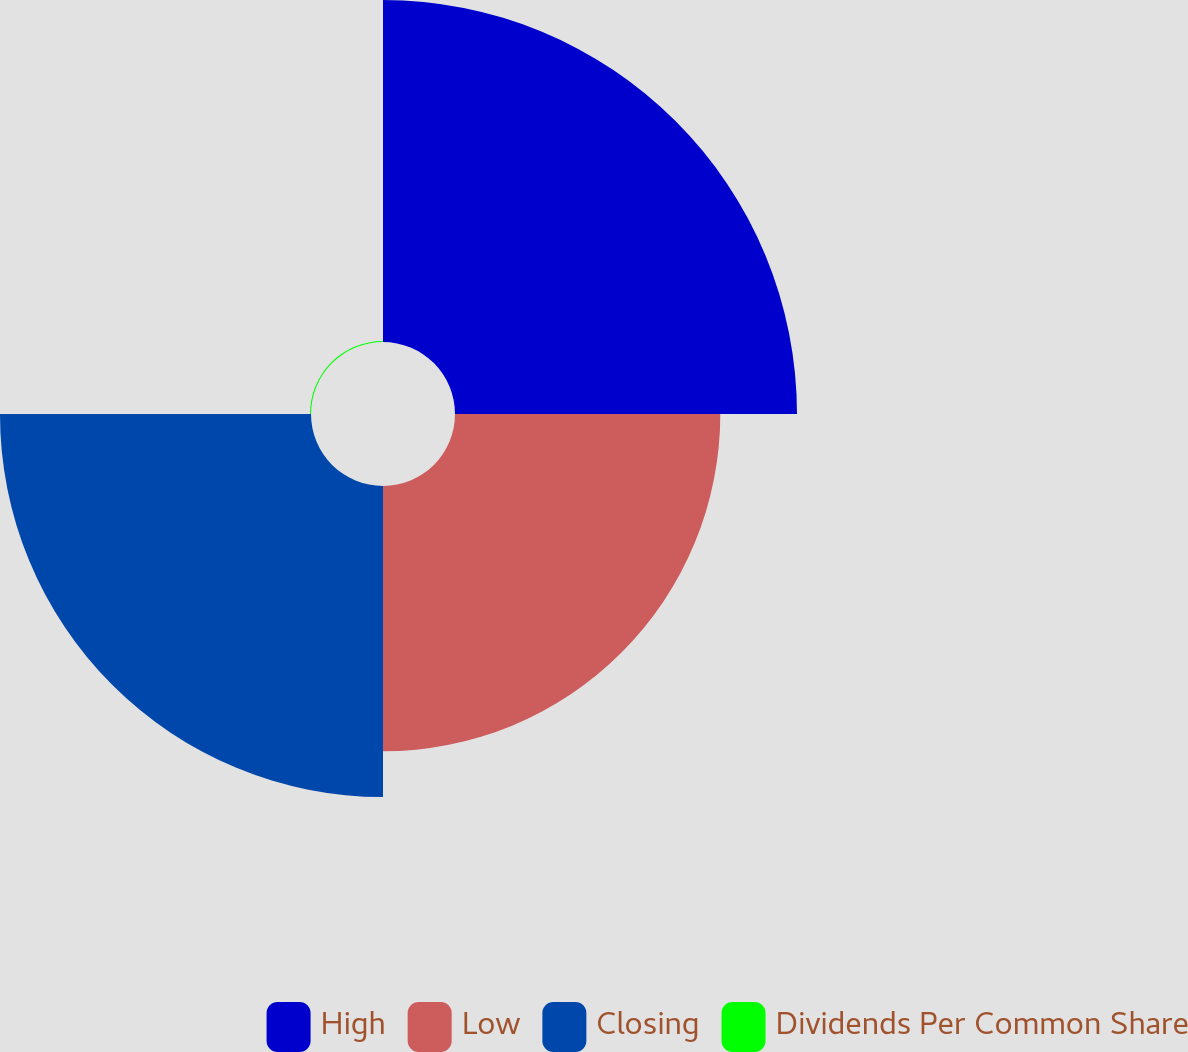<chart> <loc_0><loc_0><loc_500><loc_500><pie_chart><fcel>High<fcel>Low<fcel>Closing<fcel>Dividends Per Common Share<nl><fcel>37.2%<fcel>28.86%<fcel>33.83%<fcel>0.11%<nl></chart> 